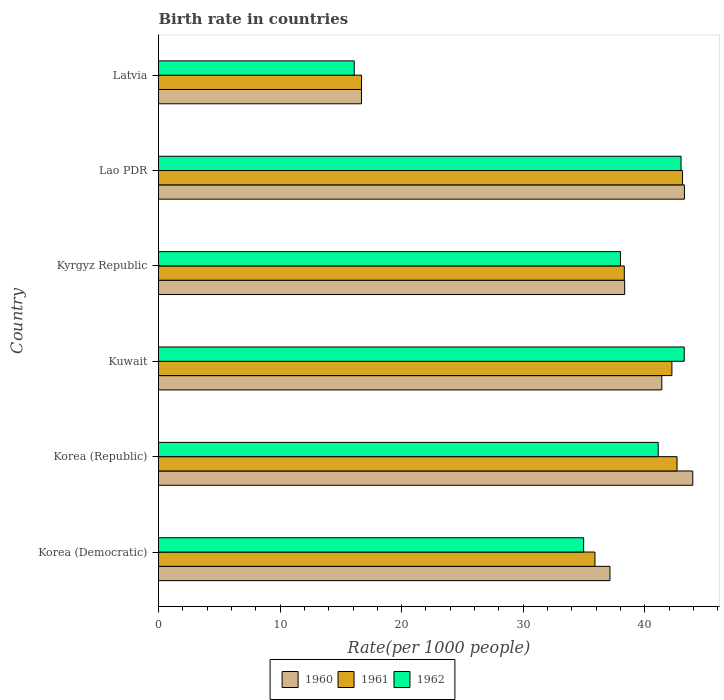Are the number of bars per tick equal to the number of legend labels?
Your answer should be very brief. Yes. How many bars are there on the 6th tick from the top?
Offer a very short reply. 3. How many bars are there on the 2nd tick from the bottom?
Your answer should be compact. 3. What is the label of the 6th group of bars from the top?
Your response must be concise. Korea (Democratic). In how many cases, is the number of bars for a given country not equal to the number of legend labels?
Your answer should be compact. 0. Across all countries, what is the maximum birth rate in 1960?
Offer a terse response. 43.95. Across all countries, what is the minimum birth rate in 1960?
Your answer should be very brief. 16.7. In which country was the birth rate in 1961 maximum?
Offer a very short reply. Lao PDR. In which country was the birth rate in 1961 minimum?
Your response must be concise. Latvia. What is the total birth rate in 1960 in the graph?
Provide a short and direct response. 220.81. What is the difference between the birth rate in 1962 in Kuwait and that in Lao PDR?
Make the answer very short. 0.26. What is the difference between the birth rate in 1960 in Korea (Democratic) and the birth rate in 1962 in Latvia?
Keep it short and to the point. 21.04. What is the average birth rate in 1960 per country?
Give a very brief answer. 36.8. What is the difference between the birth rate in 1961 and birth rate in 1960 in Kyrgyz Republic?
Provide a short and direct response. -0.03. In how many countries, is the birth rate in 1962 greater than 22 ?
Offer a terse response. 5. What is the ratio of the birth rate in 1961 in Korea (Republic) to that in Kyrgyz Republic?
Offer a very short reply. 1.11. Is the birth rate in 1961 in Kuwait less than that in Lao PDR?
Offer a very short reply. Yes. Is the difference between the birth rate in 1961 in Kyrgyz Republic and Lao PDR greater than the difference between the birth rate in 1960 in Kyrgyz Republic and Lao PDR?
Offer a very short reply. Yes. What is the difference between the highest and the second highest birth rate in 1961?
Your answer should be compact. 0.45. What is the difference between the highest and the lowest birth rate in 1960?
Your answer should be very brief. 27.25. In how many countries, is the birth rate in 1961 greater than the average birth rate in 1961 taken over all countries?
Provide a short and direct response. 4. Is the sum of the birth rate in 1962 in Kuwait and Lao PDR greater than the maximum birth rate in 1960 across all countries?
Your answer should be very brief. Yes. What does the 2nd bar from the bottom in Korea (Democratic) represents?
Your answer should be compact. 1961. Are all the bars in the graph horizontal?
Ensure brevity in your answer.  Yes. Are the values on the major ticks of X-axis written in scientific E-notation?
Make the answer very short. No. Where does the legend appear in the graph?
Give a very brief answer. Bottom center. What is the title of the graph?
Your answer should be very brief. Birth rate in countries. Does "2000" appear as one of the legend labels in the graph?
Your answer should be compact. No. What is the label or title of the X-axis?
Make the answer very short. Rate(per 1000 people). What is the Rate(per 1000 people) in 1960 in Korea (Democratic)?
Provide a short and direct response. 37.14. What is the Rate(per 1000 people) in 1961 in Korea (Democratic)?
Your answer should be compact. 35.9. What is the Rate(per 1000 people) in 1962 in Korea (Democratic)?
Offer a terse response. 34.98. What is the Rate(per 1000 people) of 1960 in Korea (Republic)?
Your response must be concise. 43.95. What is the Rate(per 1000 people) in 1961 in Korea (Republic)?
Ensure brevity in your answer.  42.66. What is the Rate(per 1000 people) of 1962 in Korea (Republic)?
Give a very brief answer. 41.11. What is the Rate(per 1000 people) in 1960 in Kuwait?
Your answer should be very brief. 41.4. What is the Rate(per 1000 people) of 1961 in Kuwait?
Offer a terse response. 42.23. What is the Rate(per 1000 people) of 1962 in Kuwait?
Your answer should be compact. 43.25. What is the Rate(per 1000 people) in 1960 in Kyrgyz Republic?
Ensure brevity in your answer.  38.35. What is the Rate(per 1000 people) of 1961 in Kyrgyz Republic?
Your answer should be very brief. 38.32. What is the Rate(per 1000 people) of 1962 in Kyrgyz Republic?
Provide a succinct answer. 38.01. What is the Rate(per 1000 people) of 1960 in Lao PDR?
Ensure brevity in your answer.  43.26. What is the Rate(per 1000 people) of 1961 in Lao PDR?
Give a very brief answer. 43.11. What is the Rate(per 1000 people) in 1962 in Lao PDR?
Offer a very short reply. 42.99. What is the Rate(per 1000 people) in 1962 in Latvia?
Offer a very short reply. 16.1. Across all countries, what is the maximum Rate(per 1000 people) in 1960?
Offer a very short reply. 43.95. Across all countries, what is the maximum Rate(per 1000 people) of 1961?
Ensure brevity in your answer.  43.11. Across all countries, what is the maximum Rate(per 1000 people) of 1962?
Provide a short and direct response. 43.25. Across all countries, what is the minimum Rate(per 1000 people) of 1960?
Your answer should be very brief. 16.7. Across all countries, what is the minimum Rate(per 1000 people) in 1961?
Make the answer very short. 16.7. Across all countries, what is the minimum Rate(per 1000 people) of 1962?
Keep it short and to the point. 16.1. What is the total Rate(per 1000 people) of 1960 in the graph?
Give a very brief answer. 220.81. What is the total Rate(per 1000 people) in 1961 in the graph?
Offer a very short reply. 218.92. What is the total Rate(per 1000 people) of 1962 in the graph?
Provide a short and direct response. 216.43. What is the difference between the Rate(per 1000 people) in 1960 in Korea (Democratic) and that in Korea (Republic)?
Keep it short and to the point. -6.81. What is the difference between the Rate(per 1000 people) of 1961 in Korea (Democratic) and that in Korea (Republic)?
Ensure brevity in your answer.  -6.75. What is the difference between the Rate(per 1000 people) of 1962 in Korea (Democratic) and that in Korea (Republic)?
Keep it short and to the point. -6.13. What is the difference between the Rate(per 1000 people) in 1960 in Korea (Democratic) and that in Kuwait?
Your answer should be compact. -4.26. What is the difference between the Rate(per 1000 people) in 1961 in Korea (Democratic) and that in Kuwait?
Your answer should be compact. -6.33. What is the difference between the Rate(per 1000 people) of 1962 in Korea (Democratic) and that in Kuwait?
Provide a short and direct response. -8.28. What is the difference between the Rate(per 1000 people) of 1960 in Korea (Democratic) and that in Kyrgyz Republic?
Make the answer very short. -1.21. What is the difference between the Rate(per 1000 people) in 1961 in Korea (Democratic) and that in Kyrgyz Republic?
Make the answer very short. -2.42. What is the difference between the Rate(per 1000 people) in 1962 in Korea (Democratic) and that in Kyrgyz Republic?
Give a very brief answer. -3.03. What is the difference between the Rate(per 1000 people) in 1960 in Korea (Democratic) and that in Lao PDR?
Keep it short and to the point. -6.12. What is the difference between the Rate(per 1000 people) of 1961 in Korea (Democratic) and that in Lao PDR?
Ensure brevity in your answer.  -7.21. What is the difference between the Rate(per 1000 people) of 1962 in Korea (Democratic) and that in Lao PDR?
Make the answer very short. -8.01. What is the difference between the Rate(per 1000 people) in 1960 in Korea (Democratic) and that in Latvia?
Your answer should be compact. 20.44. What is the difference between the Rate(per 1000 people) of 1961 in Korea (Democratic) and that in Latvia?
Keep it short and to the point. 19.2. What is the difference between the Rate(per 1000 people) of 1962 in Korea (Democratic) and that in Latvia?
Your answer should be very brief. 18.88. What is the difference between the Rate(per 1000 people) in 1960 in Korea (Republic) and that in Kuwait?
Your answer should be compact. 2.55. What is the difference between the Rate(per 1000 people) of 1961 in Korea (Republic) and that in Kuwait?
Ensure brevity in your answer.  0.42. What is the difference between the Rate(per 1000 people) in 1962 in Korea (Republic) and that in Kuwait?
Your response must be concise. -2.14. What is the difference between the Rate(per 1000 people) in 1960 in Korea (Republic) and that in Kyrgyz Republic?
Ensure brevity in your answer.  5.6. What is the difference between the Rate(per 1000 people) of 1961 in Korea (Republic) and that in Kyrgyz Republic?
Give a very brief answer. 4.34. What is the difference between the Rate(per 1000 people) in 1962 in Korea (Republic) and that in Kyrgyz Republic?
Make the answer very short. 3.1. What is the difference between the Rate(per 1000 people) of 1960 in Korea (Republic) and that in Lao PDR?
Offer a terse response. 0.69. What is the difference between the Rate(per 1000 people) of 1961 in Korea (Republic) and that in Lao PDR?
Keep it short and to the point. -0.45. What is the difference between the Rate(per 1000 people) in 1962 in Korea (Republic) and that in Lao PDR?
Keep it short and to the point. -1.88. What is the difference between the Rate(per 1000 people) in 1960 in Korea (Republic) and that in Latvia?
Offer a terse response. 27.25. What is the difference between the Rate(per 1000 people) of 1961 in Korea (Republic) and that in Latvia?
Ensure brevity in your answer.  25.96. What is the difference between the Rate(per 1000 people) in 1962 in Korea (Republic) and that in Latvia?
Offer a terse response. 25.01. What is the difference between the Rate(per 1000 people) in 1960 in Kuwait and that in Kyrgyz Republic?
Your response must be concise. 3.06. What is the difference between the Rate(per 1000 people) in 1961 in Kuwait and that in Kyrgyz Republic?
Give a very brief answer. 3.92. What is the difference between the Rate(per 1000 people) of 1962 in Kuwait and that in Kyrgyz Republic?
Provide a succinct answer. 5.25. What is the difference between the Rate(per 1000 people) of 1960 in Kuwait and that in Lao PDR?
Ensure brevity in your answer.  -1.86. What is the difference between the Rate(per 1000 people) in 1961 in Kuwait and that in Lao PDR?
Offer a very short reply. -0.87. What is the difference between the Rate(per 1000 people) of 1962 in Kuwait and that in Lao PDR?
Offer a very short reply. 0.26. What is the difference between the Rate(per 1000 people) in 1960 in Kuwait and that in Latvia?
Offer a terse response. 24.7. What is the difference between the Rate(per 1000 people) in 1961 in Kuwait and that in Latvia?
Offer a terse response. 25.54. What is the difference between the Rate(per 1000 people) of 1962 in Kuwait and that in Latvia?
Offer a terse response. 27.15. What is the difference between the Rate(per 1000 people) in 1960 in Kyrgyz Republic and that in Lao PDR?
Provide a short and direct response. -4.92. What is the difference between the Rate(per 1000 people) in 1961 in Kyrgyz Republic and that in Lao PDR?
Your answer should be compact. -4.79. What is the difference between the Rate(per 1000 people) of 1962 in Kyrgyz Republic and that in Lao PDR?
Ensure brevity in your answer.  -4.98. What is the difference between the Rate(per 1000 people) of 1960 in Kyrgyz Republic and that in Latvia?
Give a very brief answer. 21.65. What is the difference between the Rate(per 1000 people) in 1961 in Kyrgyz Republic and that in Latvia?
Keep it short and to the point. 21.62. What is the difference between the Rate(per 1000 people) of 1962 in Kyrgyz Republic and that in Latvia?
Keep it short and to the point. 21.91. What is the difference between the Rate(per 1000 people) of 1960 in Lao PDR and that in Latvia?
Your answer should be very brief. 26.56. What is the difference between the Rate(per 1000 people) of 1961 in Lao PDR and that in Latvia?
Offer a very short reply. 26.41. What is the difference between the Rate(per 1000 people) in 1962 in Lao PDR and that in Latvia?
Your answer should be very brief. 26.89. What is the difference between the Rate(per 1000 people) in 1960 in Korea (Democratic) and the Rate(per 1000 people) in 1961 in Korea (Republic)?
Your response must be concise. -5.52. What is the difference between the Rate(per 1000 people) of 1960 in Korea (Democratic) and the Rate(per 1000 people) of 1962 in Korea (Republic)?
Make the answer very short. -3.97. What is the difference between the Rate(per 1000 people) in 1961 in Korea (Democratic) and the Rate(per 1000 people) in 1962 in Korea (Republic)?
Provide a short and direct response. -5.21. What is the difference between the Rate(per 1000 people) in 1960 in Korea (Democratic) and the Rate(per 1000 people) in 1961 in Kuwait?
Offer a very short reply. -5.1. What is the difference between the Rate(per 1000 people) in 1960 in Korea (Democratic) and the Rate(per 1000 people) in 1962 in Kuwait?
Ensure brevity in your answer.  -6.11. What is the difference between the Rate(per 1000 people) in 1961 in Korea (Democratic) and the Rate(per 1000 people) in 1962 in Kuwait?
Provide a succinct answer. -7.35. What is the difference between the Rate(per 1000 people) in 1960 in Korea (Democratic) and the Rate(per 1000 people) in 1961 in Kyrgyz Republic?
Offer a terse response. -1.18. What is the difference between the Rate(per 1000 people) in 1960 in Korea (Democratic) and the Rate(per 1000 people) in 1962 in Kyrgyz Republic?
Give a very brief answer. -0.87. What is the difference between the Rate(per 1000 people) of 1961 in Korea (Democratic) and the Rate(per 1000 people) of 1962 in Kyrgyz Republic?
Your response must be concise. -2.1. What is the difference between the Rate(per 1000 people) of 1960 in Korea (Democratic) and the Rate(per 1000 people) of 1961 in Lao PDR?
Provide a succinct answer. -5.97. What is the difference between the Rate(per 1000 people) in 1960 in Korea (Democratic) and the Rate(per 1000 people) in 1962 in Lao PDR?
Make the answer very short. -5.85. What is the difference between the Rate(per 1000 people) in 1961 in Korea (Democratic) and the Rate(per 1000 people) in 1962 in Lao PDR?
Your answer should be very brief. -7.08. What is the difference between the Rate(per 1000 people) of 1960 in Korea (Democratic) and the Rate(per 1000 people) of 1961 in Latvia?
Give a very brief answer. 20.44. What is the difference between the Rate(per 1000 people) in 1960 in Korea (Democratic) and the Rate(per 1000 people) in 1962 in Latvia?
Provide a short and direct response. 21.04. What is the difference between the Rate(per 1000 people) of 1961 in Korea (Democratic) and the Rate(per 1000 people) of 1962 in Latvia?
Your answer should be compact. 19.8. What is the difference between the Rate(per 1000 people) in 1960 in Korea (Republic) and the Rate(per 1000 people) in 1961 in Kuwait?
Provide a succinct answer. 1.72. What is the difference between the Rate(per 1000 people) in 1960 in Korea (Republic) and the Rate(per 1000 people) in 1962 in Kuwait?
Make the answer very short. 0.7. What is the difference between the Rate(per 1000 people) of 1961 in Korea (Republic) and the Rate(per 1000 people) of 1962 in Kuwait?
Provide a short and direct response. -0.59. What is the difference between the Rate(per 1000 people) in 1960 in Korea (Republic) and the Rate(per 1000 people) in 1961 in Kyrgyz Republic?
Give a very brief answer. 5.63. What is the difference between the Rate(per 1000 people) of 1960 in Korea (Republic) and the Rate(per 1000 people) of 1962 in Kyrgyz Republic?
Your answer should be very brief. 5.95. What is the difference between the Rate(per 1000 people) in 1961 in Korea (Republic) and the Rate(per 1000 people) in 1962 in Kyrgyz Republic?
Give a very brief answer. 4.65. What is the difference between the Rate(per 1000 people) in 1960 in Korea (Republic) and the Rate(per 1000 people) in 1961 in Lao PDR?
Give a very brief answer. 0.84. What is the difference between the Rate(per 1000 people) in 1961 in Korea (Republic) and the Rate(per 1000 people) in 1962 in Lao PDR?
Offer a very short reply. -0.33. What is the difference between the Rate(per 1000 people) of 1960 in Korea (Republic) and the Rate(per 1000 people) of 1961 in Latvia?
Offer a terse response. 27.25. What is the difference between the Rate(per 1000 people) of 1960 in Korea (Republic) and the Rate(per 1000 people) of 1962 in Latvia?
Your answer should be very brief. 27.85. What is the difference between the Rate(per 1000 people) in 1961 in Korea (Republic) and the Rate(per 1000 people) in 1962 in Latvia?
Your response must be concise. 26.56. What is the difference between the Rate(per 1000 people) of 1960 in Kuwait and the Rate(per 1000 people) of 1961 in Kyrgyz Republic?
Provide a succinct answer. 3.08. What is the difference between the Rate(per 1000 people) in 1960 in Kuwait and the Rate(per 1000 people) in 1962 in Kyrgyz Republic?
Provide a succinct answer. 3.4. What is the difference between the Rate(per 1000 people) in 1961 in Kuwait and the Rate(per 1000 people) in 1962 in Kyrgyz Republic?
Provide a short and direct response. 4.23. What is the difference between the Rate(per 1000 people) of 1960 in Kuwait and the Rate(per 1000 people) of 1961 in Lao PDR?
Keep it short and to the point. -1.71. What is the difference between the Rate(per 1000 people) of 1960 in Kuwait and the Rate(per 1000 people) of 1962 in Lao PDR?
Ensure brevity in your answer.  -1.58. What is the difference between the Rate(per 1000 people) in 1961 in Kuwait and the Rate(per 1000 people) in 1962 in Lao PDR?
Give a very brief answer. -0.75. What is the difference between the Rate(per 1000 people) in 1960 in Kuwait and the Rate(per 1000 people) in 1961 in Latvia?
Offer a very short reply. 24.7. What is the difference between the Rate(per 1000 people) in 1960 in Kuwait and the Rate(per 1000 people) in 1962 in Latvia?
Provide a short and direct response. 25.3. What is the difference between the Rate(per 1000 people) of 1961 in Kuwait and the Rate(per 1000 people) of 1962 in Latvia?
Ensure brevity in your answer.  26.14. What is the difference between the Rate(per 1000 people) in 1960 in Kyrgyz Republic and the Rate(per 1000 people) in 1961 in Lao PDR?
Keep it short and to the point. -4.76. What is the difference between the Rate(per 1000 people) of 1960 in Kyrgyz Republic and the Rate(per 1000 people) of 1962 in Lao PDR?
Your answer should be compact. -4.64. What is the difference between the Rate(per 1000 people) in 1961 in Kyrgyz Republic and the Rate(per 1000 people) in 1962 in Lao PDR?
Provide a short and direct response. -4.67. What is the difference between the Rate(per 1000 people) in 1960 in Kyrgyz Republic and the Rate(per 1000 people) in 1961 in Latvia?
Make the answer very short. 21.65. What is the difference between the Rate(per 1000 people) of 1960 in Kyrgyz Republic and the Rate(per 1000 people) of 1962 in Latvia?
Offer a very short reply. 22.25. What is the difference between the Rate(per 1000 people) of 1961 in Kyrgyz Republic and the Rate(per 1000 people) of 1962 in Latvia?
Offer a very short reply. 22.22. What is the difference between the Rate(per 1000 people) in 1960 in Lao PDR and the Rate(per 1000 people) in 1961 in Latvia?
Keep it short and to the point. 26.56. What is the difference between the Rate(per 1000 people) in 1960 in Lao PDR and the Rate(per 1000 people) in 1962 in Latvia?
Your answer should be compact. 27.16. What is the difference between the Rate(per 1000 people) of 1961 in Lao PDR and the Rate(per 1000 people) of 1962 in Latvia?
Give a very brief answer. 27.01. What is the average Rate(per 1000 people) of 1960 per country?
Your response must be concise. 36.8. What is the average Rate(per 1000 people) of 1961 per country?
Provide a short and direct response. 36.49. What is the average Rate(per 1000 people) of 1962 per country?
Offer a terse response. 36.07. What is the difference between the Rate(per 1000 people) of 1960 and Rate(per 1000 people) of 1961 in Korea (Democratic)?
Offer a terse response. 1.24. What is the difference between the Rate(per 1000 people) in 1960 and Rate(per 1000 people) in 1962 in Korea (Democratic)?
Provide a succinct answer. 2.16. What is the difference between the Rate(per 1000 people) in 1961 and Rate(per 1000 people) in 1962 in Korea (Democratic)?
Offer a very short reply. 0.93. What is the difference between the Rate(per 1000 people) of 1960 and Rate(per 1000 people) of 1961 in Korea (Republic)?
Ensure brevity in your answer.  1.29. What is the difference between the Rate(per 1000 people) of 1960 and Rate(per 1000 people) of 1962 in Korea (Republic)?
Give a very brief answer. 2.84. What is the difference between the Rate(per 1000 people) in 1961 and Rate(per 1000 people) in 1962 in Korea (Republic)?
Ensure brevity in your answer.  1.55. What is the difference between the Rate(per 1000 people) of 1960 and Rate(per 1000 people) of 1961 in Kuwait?
Provide a succinct answer. -0.83. What is the difference between the Rate(per 1000 people) of 1960 and Rate(per 1000 people) of 1962 in Kuwait?
Your response must be concise. -1.85. What is the difference between the Rate(per 1000 people) of 1961 and Rate(per 1000 people) of 1962 in Kuwait?
Your answer should be compact. -1.01. What is the difference between the Rate(per 1000 people) of 1960 and Rate(per 1000 people) of 1961 in Kyrgyz Republic?
Keep it short and to the point. 0.03. What is the difference between the Rate(per 1000 people) in 1960 and Rate(per 1000 people) in 1962 in Kyrgyz Republic?
Your answer should be very brief. 0.34. What is the difference between the Rate(per 1000 people) of 1961 and Rate(per 1000 people) of 1962 in Kyrgyz Republic?
Offer a very short reply. 0.31. What is the difference between the Rate(per 1000 people) in 1960 and Rate(per 1000 people) in 1961 in Lao PDR?
Your answer should be compact. 0.15. What is the difference between the Rate(per 1000 people) in 1960 and Rate(per 1000 people) in 1962 in Lao PDR?
Give a very brief answer. 0.28. What is the difference between the Rate(per 1000 people) in 1961 and Rate(per 1000 people) in 1962 in Lao PDR?
Provide a short and direct response. 0.12. What is the ratio of the Rate(per 1000 people) in 1960 in Korea (Democratic) to that in Korea (Republic)?
Offer a terse response. 0.84. What is the ratio of the Rate(per 1000 people) in 1961 in Korea (Democratic) to that in Korea (Republic)?
Give a very brief answer. 0.84. What is the ratio of the Rate(per 1000 people) in 1962 in Korea (Democratic) to that in Korea (Republic)?
Provide a short and direct response. 0.85. What is the ratio of the Rate(per 1000 people) of 1960 in Korea (Democratic) to that in Kuwait?
Make the answer very short. 0.9. What is the ratio of the Rate(per 1000 people) of 1961 in Korea (Democratic) to that in Kuwait?
Offer a very short reply. 0.85. What is the ratio of the Rate(per 1000 people) in 1962 in Korea (Democratic) to that in Kuwait?
Your answer should be very brief. 0.81. What is the ratio of the Rate(per 1000 people) in 1960 in Korea (Democratic) to that in Kyrgyz Republic?
Your answer should be compact. 0.97. What is the ratio of the Rate(per 1000 people) in 1961 in Korea (Democratic) to that in Kyrgyz Republic?
Offer a terse response. 0.94. What is the ratio of the Rate(per 1000 people) of 1962 in Korea (Democratic) to that in Kyrgyz Republic?
Provide a short and direct response. 0.92. What is the ratio of the Rate(per 1000 people) of 1960 in Korea (Democratic) to that in Lao PDR?
Provide a short and direct response. 0.86. What is the ratio of the Rate(per 1000 people) in 1961 in Korea (Democratic) to that in Lao PDR?
Your response must be concise. 0.83. What is the ratio of the Rate(per 1000 people) in 1962 in Korea (Democratic) to that in Lao PDR?
Give a very brief answer. 0.81. What is the ratio of the Rate(per 1000 people) in 1960 in Korea (Democratic) to that in Latvia?
Give a very brief answer. 2.22. What is the ratio of the Rate(per 1000 people) of 1961 in Korea (Democratic) to that in Latvia?
Your response must be concise. 2.15. What is the ratio of the Rate(per 1000 people) in 1962 in Korea (Democratic) to that in Latvia?
Your answer should be compact. 2.17. What is the ratio of the Rate(per 1000 people) of 1960 in Korea (Republic) to that in Kuwait?
Your answer should be very brief. 1.06. What is the ratio of the Rate(per 1000 people) of 1961 in Korea (Republic) to that in Kuwait?
Offer a terse response. 1.01. What is the ratio of the Rate(per 1000 people) in 1962 in Korea (Republic) to that in Kuwait?
Give a very brief answer. 0.95. What is the ratio of the Rate(per 1000 people) of 1960 in Korea (Republic) to that in Kyrgyz Republic?
Offer a terse response. 1.15. What is the ratio of the Rate(per 1000 people) of 1961 in Korea (Republic) to that in Kyrgyz Republic?
Keep it short and to the point. 1.11. What is the ratio of the Rate(per 1000 people) in 1962 in Korea (Republic) to that in Kyrgyz Republic?
Give a very brief answer. 1.08. What is the ratio of the Rate(per 1000 people) of 1960 in Korea (Republic) to that in Lao PDR?
Give a very brief answer. 1.02. What is the ratio of the Rate(per 1000 people) of 1961 in Korea (Republic) to that in Lao PDR?
Offer a very short reply. 0.99. What is the ratio of the Rate(per 1000 people) in 1962 in Korea (Republic) to that in Lao PDR?
Give a very brief answer. 0.96. What is the ratio of the Rate(per 1000 people) in 1960 in Korea (Republic) to that in Latvia?
Your response must be concise. 2.63. What is the ratio of the Rate(per 1000 people) of 1961 in Korea (Republic) to that in Latvia?
Make the answer very short. 2.55. What is the ratio of the Rate(per 1000 people) in 1962 in Korea (Republic) to that in Latvia?
Provide a short and direct response. 2.55. What is the ratio of the Rate(per 1000 people) of 1960 in Kuwait to that in Kyrgyz Republic?
Provide a succinct answer. 1.08. What is the ratio of the Rate(per 1000 people) of 1961 in Kuwait to that in Kyrgyz Republic?
Offer a very short reply. 1.1. What is the ratio of the Rate(per 1000 people) of 1962 in Kuwait to that in Kyrgyz Republic?
Your response must be concise. 1.14. What is the ratio of the Rate(per 1000 people) in 1961 in Kuwait to that in Lao PDR?
Provide a succinct answer. 0.98. What is the ratio of the Rate(per 1000 people) in 1962 in Kuwait to that in Lao PDR?
Keep it short and to the point. 1.01. What is the ratio of the Rate(per 1000 people) of 1960 in Kuwait to that in Latvia?
Provide a short and direct response. 2.48. What is the ratio of the Rate(per 1000 people) in 1961 in Kuwait to that in Latvia?
Keep it short and to the point. 2.53. What is the ratio of the Rate(per 1000 people) in 1962 in Kuwait to that in Latvia?
Your response must be concise. 2.69. What is the ratio of the Rate(per 1000 people) in 1960 in Kyrgyz Republic to that in Lao PDR?
Your response must be concise. 0.89. What is the ratio of the Rate(per 1000 people) in 1961 in Kyrgyz Republic to that in Lao PDR?
Provide a succinct answer. 0.89. What is the ratio of the Rate(per 1000 people) in 1962 in Kyrgyz Republic to that in Lao PDR?
Your answer should be very brief. 0.88. What is the ratio of the Rate(per 1000 people) of 1960 in Kyrgyz Republic to that in Latvia?
Provide a short and direct response. 2.3. What is the ratio of the Rate(per 1000 people) of 1961 in Kyrgyz Republic to that in Latvia?
Provide a short and direct response. 2.29. What is the ratio of the Rate(per 1000 people) of 1962 in Kyrgyz Republic to that in Latvia?
Your answer should be compact. 2.36. What is the ratio of the Rate(per 1000 people) of 1960 in Lao PDR to that in Latvia?
Make the answer very short. 2.59. What is the ratio of the Rate(per 1000 people) of 1961 in Lao PDR to that in Latvia?
Your response must be concise. 2.58. What is the ratio of the Rate(per 1000 people) of 1962 in Lao PDR to that in Latvia?
Give a very brief answer. 2.67. What is the difference between the highest and the second highest Rate(per 1000 people) in 1960?
Give a very brief answer. 0.69. What is the difference between the highest and the second highest Rate(per 1000 people) in 1961?
Offer a terse response. 0.45. What is the difference between the highest and the second highest Rate(per 1000 people) of 1962?
Ensure brevity in your answer.  0.26. What is the difference between the highest and the lowest Rate(per 1000 people) of 1960?
Your response must be concise. 27.25. What is the difference between the highest and the lowest Rate(per 1000 people) of 1961?
Offer a terse response. 26.41. What is the difference between the highest and the lowest Rate(per 1000 people) of 1962?
Make the answer very short. 27.15. 